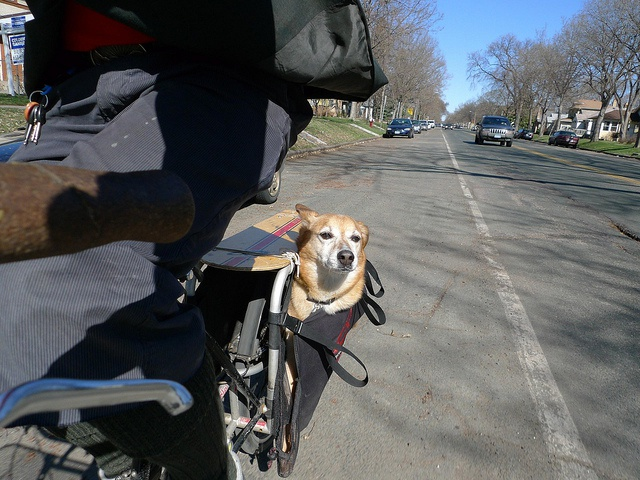Describe the objects in this image and their specific colors. I can see people in brown, black, gray, and purple tones, people in brown, black, maroon, and gray tones, dog in brown, gray, ivory, black, and tan tones, skateboard in brown, gray, tan, and black tones, and truck in brown, black, gray, navy, and darkgray tones in this image. 